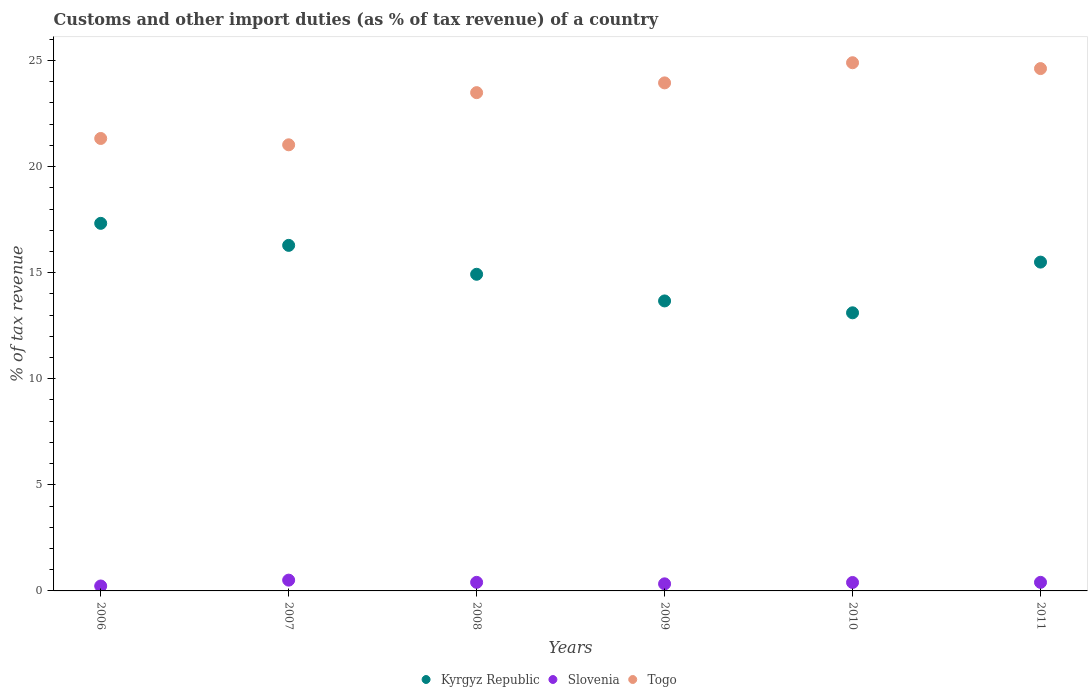How many different coloured dotlines are there?
Offer a very short reply. 3. Is the number of dotlines equal to the number of legend labels?
Keep it short and to the point. Yes. What is the percentage of tax revenue from customs in Kyrgyz Republic in 2007?
Offer a terse response. 16.29. Across all years, what is the maximum percentage of tax revenue from customs in Togo?
Your answer should be compact. 24.89. Across all years, what is the minimum percentage of tax revenue from customs in Togo?
Your response must be concise. 21.03. In which year was the percentage of tax revenue from customs in Slovenia minimum?
Provide a short and direct response. 2006. What is the total percentage of tax revenue from customs in Kyrgyz Republic in the graph?
Give a very brief answer. 90.81. What is the difference between the percentage of tax revenue from customs in Kyrgyz Republic in 2009 and that in 2010?
Give a very brief answer. 0.56. What is the difference between the percentage of tax revenue from customs in Kyrgyz Republic in 2011 and the percentage of tax revenue from customs in Togo in 2008?
Your response must be concise. -7.99. What is the average percentage of tax revenue from customs in Kyrgyz Republic per year?
Make the answer very short. 15.14. In the year 2011, what is the difference between the percentage of tax revenue from customs in Slovenia and percentage of tax revenue from customs in Kyrgyz Republic?
Your response must be concise. -15.1. What is the ratio of the percentage of tax revenue from customs in Togo in 2006 to that in 2009?
Offer a terse response. 0.89. Is the percentage of tax revenue from customs in Togo in 2009 less than that in 2011?
Ensure brevity in your answer.  Yes. What is the difference between the highest and the second highest percentage of tax revenue from customs in Kyrgyz Republic?
Your answer should be very brief. 1.04. What is the difference between the highest and the lowest percentage of tax revenue from customs in Kyrgyz Republic?
Provide a short and direct response. 4.22. In how many years, is the percentage of tax revenue from customs in Slovenia greater than the average percentage of tax revenue from customs in Slovenia taken over all years?
Your response must be concise. 4. Does the percentage of tax revenue from customs in Togo monotonically increase over the years?
Ensure brevity in your answer.  No. How many dotlines are there?
Keep it short and to the point. 3. How many years are there in the graph?
Keep it short and to the point. 6. Does the graph contain any zero values?
Your response must be concise. No. Does the graph contain grids?
Offer a very short reply. No. What is the title of the graph?
Your answer should be very brief. Customs and other import duties (as % of tax revenue) of a country. What is the label or title of the Y-axis?
Keep it short and to the point. % of tax revenue. What is the % of tax revenue in Kyrgyz Republic in 2006?
Ensure brevity in your answer.  17.32. What is the % of tax revenue in Slovenia in 2006?
Give a very brief answer. 0.23. What is the % of tax revenue in Togo in 2006?
Provide a short and direct response. 21.33. What is the % of tax revenue in Kyrgyz Republic in 2007?
Your answer should be compact. 16.29. What is the % of tax revenue in Slovenia in 2007?
Provide a succinct answer. 0.51. What is the % of tax revenue in Togo in 2007?
Keep it short and to the point. 21.03. What is the % of tax revenue of Kyrgyz Republic in 2008?
Provide a short and direct response. 14.92. What is the % of tax revenue of Slovenia in 2008?
Provide a succinct answer. 0.4. What is the % of tax revenue in Togo in 2008?
Your answer should be very brief. 23.48. What is the % of tax revenue of Kyrgyz Republic in 2009?
Give a very brief answer. 13.67. What is the % of tax revenue of Slovenia in 2009?
Give a very brief answer. 0.33. What is the % of tax revenue in Togo in 2009?
Give a very brief answer. 23.95. What is the % of tax revenue of Kyrgyz Republic in 2010?
Offer a very short reply. 13.11. What is the % of tax revenue in Slovenia in 2010?
Ensure brevity in your answer.  0.4. What is the % of tax revenue in Togo in 2010?
Make the answer very short. 24.89. What is the % of tax revenue in Kyrgyz Republic in 2011?
Offer a very short reply. 15.5. What is the % of tax revenue of Slovenia in 2011?
Offer a very short reply. 0.4. What is the % of tax revenue in Togo in 2011?
Provide a short and direct response. 24.62. Across all years, what is the maximum % of tax revenue in Kyrgyz Republic?
Make the answer very short. 17.32. Across all years, what is the maximum % of tax revenue in Slovenia?
Offer a very short reply. 0.51. Across all years, what is the maximum % of tax revenue of Togo?
Offer a terse response. 24.89. Across all years, what is the minimum % of tax revenue of Kyrgyz Republic?
Offer a terse response. 13.11. Across all years, what is the minimum % of tax revenue of Slovenia?
Make the answer very short. 0.23. Across all years, what is the minimum % of tax revenue of Togo?
Offer a terse response. 21.03. What is the total % of tax revenue of Kyrgyz Republic in the graph?
Make the answer very short. 90.81. What is the total % of tax revenue in Slovenia in the graph?
Offer a terse response. 2.28. What is the total % of tax revenue in Togo in the graph?
Give a very brief answer. 139.3. What is the difference between the % of tax revenue in Kyrgyz Republic in 2006 and that in 2007?
Offer a terse response. 1.04. What is the difference between the % of tax revenue in Slovenia in 2006 and that in 2007?
Make the answer very short. -0.28. What is the difference between the % of tax revenue in Togo in 2006 and that in 2007?
Your answer should be compact. 0.3. What is the difference between the % of tax revenue of Kyrgyz Republic in 2006 and that in 2008?
Offer a very short reply. 2.4. What is the difference between the % of tax revenue of Slovenia in 2006 and that in 2008?
Offer a terse response. -0.17. What is the difference between the % of tax revenue of Togo in 2006 and that in 2008?
Your answer should be very brief. -2.16. What is the difference between the % of tax revenue in Kyrgyz Republic in 2006 and that in 2009?
Ensure brevity in your answer.  3.66. What is the difference between the % of tax revenue in Slovenia in 2006 and that in 2009?
Ensure brevity in your answer.  -0.1. What is the difference between the % of tax revenue in Togo in 2006 and that in 2009?
Your response must be concise. -2.62. What is the difference between the % of tax revenue in Kyrgyz Republic in 2006 and that in 2010?
Ensure brevity in your answer.  4.22. What is the difference between the % of tax revenue of Slovenia in 2006 and that in 2010?
Your response must be concise. -0.17. What is the difference between the % of tax revenue of Togo in 2006 and that in 2010?
Provide a succinct answer. -3.57. What is the difference between the % of tax revenue of Kyrgyz Republic in 2006 and that in 2011?
Provide a short and direct response. 1.83. What is the difference between the % of tax revenue of Slovenia in 2006 and that in 2011?
Offer a terse response. -0.17. What is the difference between the % of tax revenue of Togo in 2006 and that in 2011?
Provide a short and direct response. -3.29. What is the difference between the % of tax revenue of Kyrgyz Republic in 2007 and that in 2008?
Provide a succinct answer. 1.36. What is the difference between the % of tax revenue of Slovenia in 2007 and that in 2008?
Provide a succinct answer. 0.1. What is the difference between the % of tax revenue in Togo in 2007 and that in 2008?
Make the answer very short. -2.46. What is the difference between the % of tax revenue in Kyrgyz Republic in 2007 and that in 2009?
Give a very brief answer. 2.62. What is the difference between the % of tax revenue in Slovenia in 2007 and that in 2009?
Provide a short and direct response. 0.17. What is the difference between the % of tax revenue in Togo in 2007 and that in 2009?
Your response must be concise. -2.92. What is the difference between the % of tax revenue in Kyrgyz Republic in 2007 and that in 2010?
Give a very brief answer. 3.18. What is the difference between the % of tax revenue of Slovenia in 2007 and that in 2010?
Your response must be concise. 0.11. What is the difference between the % of tax revenue of Togo in 2007 and that in 2010?
Your answer should be very brief. -3.87. What is the difference between the % of tax revenue in Kyrgyz Republic in 2007 and that in 2011?
Give a very brief answer. 0.79. What is the difference between the % of tax revenue in Slovenia in 2007 and that in 2011?
Make the answer very short. 0.11. What is the difference between the % of tax revenue of Togo in 2007 and that in 2011?
Ensure brevity in your answer.  -3.59. What is the difference between the % of tax revenue in Kyrgyz Republic in 2008 and that in 2009?
Give a very brief answer. 1.26. What is the difference between the % of tax revenue in Slovenia in 2008 and that in 2009?
Your response must be concise. 0.07. What is the difference between the % of tax revenue in Togo in 2008 and that in 2009?
Your response must be concise. -0.46. What is the difference between the % of tax revenue of Kyrgyz Republic in 2008 and that in 2010?
Ensure brevity in your answer.  1.82. What is the difference between the % of tax revenue of Slovenia in 2008 and that in 2010?
Your answer should be very brief. 0.01. What is the difference between the % of tax revenue of Togo in 2008 and that in 2010?
Provide a succinct answer. -1.41. What is the difference between the % of tax revenue of Kyrgyz Republic in 2008 and that in 2011?
Your answer should be very brief. -0.57. What is the difference between the % of tax revenue in Togo in 2008 and that in 2011?
Offer a terse response. -1.13. What is the difference between the % of tax revenue in Kyrgyz Republic in 2009 and that in 2010?
Offer a very short reply. 0.56. What is the difference between the % of tax revenue in Slovenia in 2009 and that in 2010?
Your answer should be very brief. -0.06. What is the difference between the % of tax revenue of Togo in 2009 and that in 2010?
Offer a terse response. -0.95. What is the difference between the % of tax revenue of Kyrgyz Republic in 2009 and that in 2011?
Offer a very short reply. -1.83. What is the difference between the % of tax revenue in Slovenia in 2009 and that in 2011?
Your answer should be compact. -0.07. What is the difference between the % of tax revenue in Togo in 2009 and that in 2011?
Offer a very short reply. -0.67. What is the difference between the % of tax revenue of Kyrgyz Republic in 2010 and that in 2011?
Your answer should be compact. -2.39. What is the difference between the % of tax revenue in Slovenia in 2010 and that in 2011?
Give a very brief answer. -0. What is the difference between the % of tax revenue in Togo in 2010 and that in 2011?
Offer a very short reply. 0.28. What is the difference between the % of tax revenue of Kyrgyz Republic in 2006 and the % of tax revenue of Slovenia in 2007?
Offer a very short reply. 16.82. What is the difference between the % of tax revenue in Kyrgyz Republic in 2006 and the % of tax revenue in Togo in 2007?
Your response must be concise. -3.7. What is the difference between the % of tax revenue in Slovenia in 2006 and the % of tax revenue in Togo in 2007?
Your answer should be very brief. -20.79. What is the difference between the % of tax revenue of Kyrgyz Republic in 2006 and the % of tax revenue of Slovenia in 2008?
Offer a terse response. 16.92. What is the difference between the % of tax revenue of Kyrgyz Republic in 2006 and the % of tax revenue of Togo in 2008?
Provide a short and direct response. -6.16. What is the difference between the % of tax revenue in Slovenia in 2006 and the % of tax revenue in Togo in 2008?
Offer a very short reply. -23.25. What is the difference between the % of tax revenue in Kyrgyz Republic in 2006 and the % of tax revenue in Slovenia in 2009?
Make the answer very short. 16.99. What is the difference between the % of tax revenue of Kyrgyz Republic in 2006 and the % of tax revenue of Togo in 2009?
Your response must be concise. -6.62. What is the difference between the % of tax revenue of Slovenia in 2006 and the % of tax revenue of Togo in 2009?
Make the answer very short. -23.71. What is the difference between the % of tax revenue of Kyrgyz Republic in 2006 and the % of tax revenue of Slovenia in 2010?
Give a very brief answer. 16.93. What is the difference between the % of tax revenue of Kyrgyz Republic in 2006 and the % of tax revenue of Togo in 2010?
Your answer should be compact. -7.57. What is the difference between the % of tax revenue in Slovenia in 2006 and the % of tax revenue in Togo in 2010?
Make the answer very short. -24.66. What is the difference between the % of tax revenue in Kyrgyz Republic in 2006 and the % of tax revenue in Slovenia in 2011?
Your answer should be very brief. 16.92. What is the difference between the % of tax revenue in Kyrgyz Republic in 2006 and the % of tax revenue in Togo in 2011?
Offer a terse response. -7.29. What is the difference between the % of tax revenue in Slovenia in 2006 and the % of tax revenue in Togo in 2011?
Provide a short and direct response. -24.39. What is the difference between the % of tax revenue in Kyrgyz Republic in 2007 and the % of tax revenue in Slovenia in 2008?
Offer a very short reply. 15.88. What is the difference between the % of tax revenue in Kyrgyz Republic in 2007 and the % of tax revenue in Togo in 2008?
Your response must be concise. -7.2. What is the difference between the % of tax revenue in Slovenia in 2007 and the % of tax revenue in Togo in 2008?
Your response must be concise. -22.98. What is the difference between the % of tax revenue in Kyrgyz Republic in 2007 and the % of tax revenue in Slovenia in 2009?
Give a very brief answer. 15.95. What is the difference between the % of tax revenue in Kyrgyz Republic in 2007 and the % of tax revenue in Togo in 2009?
Your answer should be compact. -7.66. What is the difference between the % of tax revenue of Slovenia in 2007 and the % of tax revenue of Togo in 2009?
Your response must be concise. -23.44. What is the difference between the % of tax revenue of Kyrgyz Republic in 2007 and the % of tax revenue of Slovenia in 2010?
Provide a succinct answer. 15.89. What is the difference between the % of tax revenue in Kyrgyz Republic in 2007 and the % of tax revenue in Togo in 2010?
Offer a very short reply. -8.61. What is the difference between the % of tax revenue of Slovenia in 2007 and the % of tax revenue of Togo in 2010?
Provide a succinct answer. -24.39. What is the difference between the % of tax revenue in Kyrgyz Republic in 2007 and the % of tax revenue in Slovenia in 2011?
Keep it short and to the point. 15.88. What is the difference between the % of tax revenue of Kyrgyz Republic in 2007 and the % of tax revenue of Togo in 2011?
Provide a succinct answer. -8.33. What is the difference between the % of tax revenue of Slovenia in 2007 and the % of tax revenue of Togo in 2011?
Offer a very short reply. -24.11. What is the difference between the % of tax revenue in Kyrgyz Republic in 2008 and the % of tax revenue in Slovenia in 2009?
Provide a succinct answer. 14.59. What is the difference between the % of tax revenue in Kyrgyz Republic in 2008 and the % of tax revenue in Togo in 2009?
Your answer should be very brief. -9.02. What is the difference between the % of tax revenue in Slovenia in 2008 and the % of tax revenue in Togo in 2009?
Ensure brevity in your answer.  -23.54. What is the difference between the % of tax revenue in Kyrgyz Republic in 2008 and the % of tax revenue in Slovenia in 2010?
Ensure brevity in your answer.  14.53. What is the difference between the % of tax revenue in Kyrgyz Republic in 2008 and the % of tax revenue in Togo in 2010?
Ensure brevity in your answer.  -9.97. What is the difference between the % of tax revenue of Slovenia in 2008 and the % of tax revenue of Togo in 2010?
Offer a terse response. -24.49. What is the difference between the % of tax revenue of Kyrgyz Republic in 2008 and the % of tax revenue of Slovenia in 2011?
Provide a short and direct response. 14.52. What is the difference between the % of tax revenue of Kyrgyz Republic in 2008 and the % of tax revenue of Togo in 2011?
Give a very brief answer. -9.69. What is the difference between the % of tax revenue in Slovenia in 2008 and the % of tax revenue in Togo in 2011?
Provide a short and direct response. -24.21. What is the difference between the % of tax revenue in Kyrgyz Republic in 2009 and the % of tax revenue in Slovenia in 2010?
Provide a succinct answer. 13.27. What is the difference between the % of tax revenue of Kyrgyz Republic in 2009 and the % of tax revenue of Togo in 2010?
Offer a terse response. -11.23. What is the difference between the % of tax revenue of Slovenia in 2009 and the % of tax revenue of Togo in 2010?
Provide a succinct answer. -24.56. What is the difference between the % of tax revenue of Kyrgyz Republic in 2009 and the % of tax revenue of Slovenia in 2011?
Make the answer very short. 13.26. What is the difference between the % of tax revenue of Kyrgyz Republic in 2009 and the % of tax revenue of Togo in 2011?
Your answer should be very brief. -10.95. What is the difference between the % of tax revenue of Slovenia in 2009 and the % of tax revenue of Togo in 2011?
Your answer should be very brief. -24.29. What is the difference between the % of tax revenue of Kyrgyz Republic in 2010 and the % of tax revenue of Slovenia in 2011?
Ensure brevity in your answer.  12.71. What is the difference between the % of tax revenue of Kyrgyz Republic in 2010 and the % of tax revenue of Togo in 2011?
Make the answer very short. -11.51. What is the difference between the % of tax revenue in Slovenia in 2010 and the % of tax revenue in Togo in 2011?
Provide a short and direct response. -24.22. What is the average % of tax revenue of Kyrgyz Republic per year?
Offer a very short reply. 15.14. What is the average % of tax revenue in Slovenia per year?
Your answer should be compact. 0.38. What is the average % of tax revenue in Togo per year?
Make the answer very short. 23.22. In the year 2006, what is the difference between the % of tax revenue in Kyrgyz Republic and % of tax revenue in Slovenia?
Give a very brief answer. 17.09. In the year 2006, what is the difference between the % of tax revenue of Kyrgyz Republic and % of tax revenue of Togo?
Provide a succinct answer. -4. In the year 2006, what is the difference between the % of tax revenue in Slovenia and % of tax revenue in Togo?
Give a very brief answer. -21.09. In the year 2007, what is the difference between the % of tax revenue of Kyrgyz Republic and % of tax revenue of Slovenia?
Give a very brief answer. 15.78. In the year 2007, what is the difference between the % of tax revenue in Kyrgyz Republic and % of tax revenue in Togo?
Provide a short and direct response. -4.74. In the year 2007, what is the difference between the % of tax revenue of Slovenia and % of tax revenue of Togo?
Make the answer very short. -20.52. In the year 2008, what is the difference between the % of tax revenue in Kyrgyz Republic and % of tax revenue in Slovenia?
Offer a very short reply. 14.52. In the year 2008, what is the difference between the % of tax revenue of Kyrgyz Republic and % of tax revenue of Togo?
Make the answer very short. -8.56. In the year 2008, what is the difference between the % of tax revenue in Slovenia and % of tax revenue in Togo?
Keep it short and to the point. -23.08. In the year 2009, what is the difference between the % of tax revenue of Kyrgyz Republic and % of tax revenue of Slovenia?
Provide a short and direct response. 13.33. In the year 2009, what is the difference between the % of tax revenue of Kyrgyz Republic and % of tax revenue of Togo?
Your response must be concise. -10.28. In the year 2009, what is the difference between the % of tax revenue of Slovenia and % of tax revenue of Togo?
Provide a short and direct response. -23.61. In the year 2010, what is the difference between the % of tax revenue of Kyrgyz Republic and % of tax revenue of Slovenia?
Provide a succinct answer. 12.71. In the year 2010, what is the difference between the % of tax revenue of Kyrgyz Republic and % of tax revenue of Togo?
Provide a succinct answer. -11.79. In the year 2010, what is the difference between the % of tax revenue of Slovenia and % of tax revenue of Togo?
Offer a very short reply. -24.5. In the year 2011, what is the difference between the % of tax revenue of Kyrgyz Republic and % of tax revenue of Slovenia?
Provide a succinct answer. 15.1. In the year 2011, what is the difference between the % of tax revenue of Kyrgyz Republic and % of tax revenue of Togo?
Your response must be concise. -9.12. In the year 2011, what is the difference between the % of tax revenue of Slovenia and % of tax revenue of Togo?
Your response must be concise. -24.22. What is the ratio of the % of tax revenue in Kyrgyz Republic in 2006 to that in 2007?
Provide a short and direct response. 1.06. What is the ratio of the % of tax revenue of Slovenia in 2006 to that in 2007?
Your response must be concise. 0.46. What is the ratio of the % of tax revenue of Togo in 2006 to that in 2007?
Make the answer very short. 1.01. What is the ratio of the % of tax revenue of Kyrgyz Republic in 2006 to that in 2008?
Offer a very short reply. 1.16. What is the ratio of the % of tax revenue of Slovenia in 2006 to that in 2008?
Provide a short and direct response. 0.58. What is the ratio of the % of tax revenue in Togo in 2006 to that in 2008?
Provide a short and direct response. 0.91. What is the ratio of the % of tax revenue in Kyrgyz Republic in 2006 to that in 2009?
Provide a short and direct response. 1.27. What is the ratio of the % of tax revenue in Slovenia in 2006 to that in 2009?
Keep it short and to the point. 0.7. What is the ratio of the % of tax revenue in Togo in 2006 to that in 2009?
Offer a terse response. 0.89. What is the ratio of the % of tax revenue of Kyrgyz Republic in 2006 to that in 2010?
Offer a terse response. 1.32. What is the ratio of the % of tax revenue in Slovenia in 2006 to that in 2010?
Your response must be concise. 0.58. What is the ratio of the % of tax revenue of Togo in 2006 to that in 2010?
Keep it short and to the point. 0.86. What is the ratio of the % of tax revenue in Kyrgyz Republic in 2006 to that in 2011?
Keep it short and to the point. 1.12. What is the ratio of the % of tax revenue of Slovenia in 2006 to that in 2011?
Offer a very short reply. 0.58. What is the ratio of the % of tax revenue in Togo in 2006 to that in 2011?
Offer a terse response. 0.87. What is the ratio of the % of tax revenue in Kyrgyz Republic in 2007 to that in 2008?
Ensure brevity in your answer.  1.09. What is the ratio of the % of tax revenue in Slovenia in 2007 to that in 2008?
Make the answer very short. 1.26. What is the ratio of the % of tax revenue of Togo in 2007 to that in 2008?
Provide a short and direct response. 0.9. What is the ratio of the % of tax revenue in Kyrgyz Republic in 2007 to that in 2009?
Your answer should be compact. 1.19. What is the ratio of the % of tax revenue of Slovenia in 2007 to that in 2009?
Ensure brevity in your answer.  1.52. What is the ratio of the % of tax revenue of Togo in 2007 to that in 2009?
Your response must be concise. 0.88. What is the ratio of the % of tax revenue of Kyrgyz Republic in 2007 to that in 2010?
Your answer should be compact. 1.24. What is the ratio of the % of tax revenue of Slovenia in 2007 to that in 2010?
Your response must be concise. 1.28. What is the ratio of the % of tax revenue in Togo in 2007 to that in 2010?
Your answer should be compact. 0.84. What is the ratio of the % of tax revenue in Kyrgyz Republic in 2007 to that in 2011?
Make the answer very short. 1.05. What is the ratio of the % of tax revenue in Slovenia in 2007 to that in 2011?
Offer a terse response. 1.26. What is the ratio of the % of tax revenue in Togo in 2007 to that in 2011?
Give a very brief answer. 0.85. What is the ratio of the % of tax revenue in Kyrgyz Republic in 2008 to that in 2009?
Your answer should be compact. 1.09. What is the ratio of the % of tax revenue of Slovenia in 2008 to that in 2009?
Your answer should be compact. 1.21. What is the ratio of the % of tax revenue of Togo in 2008 to that in 2009?
Provide a succinct answer. 0.98. What is the ratio of the % of tax revenue in Kyrgyz Republic in 2008 to that in 2010?
Give a very brief answer. 1.14. What is the ratio of the % of tax revenue in Slovenia in 2008 to that in 2010?
Your answer should be very brief. 1.01. What is the ratio of the % of tax revenue of Togo in 2008 to that in 2010?
Give a very brief answer. 0.94. What is the ratio of the % of tax revenue in Kyrgyz Republic in 2008 to that in 2011?
Offer a terse response. 0.96. What is the ratio of the % of tax revenue of Slovenia in 2008 to that in 2011?
Your response must be concise. 1. What is the ratio of the % of tax revenue in Togo in 2008 to that in 2011?
Your answer should be very brief. 0.95. What is the ratio of the % of tax revenue in Kyrgyz Republic in 2009 to that in 2010?
Provide a succinct answer. 1.04. What is the ratio of the % of tax revenue of Slovenia in 2009 to that in 2010?
Give a very brief answer. 0.84. What is the ratio of the % of tax revenue in Togo in 2009 to that in 2010?
Provide a succinct answer. 0.96. What is the ratio of the % of tax revenue in Kyrgyz Republic in 2009 to that in 2011?
Your response must be concise. 0.88. What is the ratio of the % of tax revenue of Slovenia in 2009 to that in 2011?
Keep it short and to the point. 0.83. What is the ratio of the % of tax revenue in Togo in 2009 to that in 2011?
Make the answer very short. 0.97. What is the ratio of the % of tax revenue of Kyrgyz Republic in 2010 to that in 2011?
Your answer should be compact. 0.85. What is the ratio of the % of tax revenue of Slovenia in 2010 to that in 2011?
Keep it short and to the point. 0.99. What is the ratio of the % of tax revenue in Togo in 2010 to that in 2011?
Your answer should be compact. 1.01. What is the difference between the highest and the second highest % of tax revenue in Kyrgyz Republic?
Provide a succinct answer. 1.04. What is the difference between the highest and the second highest % of tax revenue in Slovenia?
Provide a succinct answer. 0.1. What is the difference between the highest and the second highest % of tax revenue in Togo?
Keep it short and to the point. 0.28. What is the difference between the highest and the lowest % of tax revenue in Kyrgyz Republic?
Your answer should be compact. 4.22. What is the difference between the highest and the lowest % of tax revenue of Slovenia?
Make the answer very short. 0.28. What is the difference between the highest and the lowest % of tax revenue of Togo?
Give a very brief answer. 3.87. 